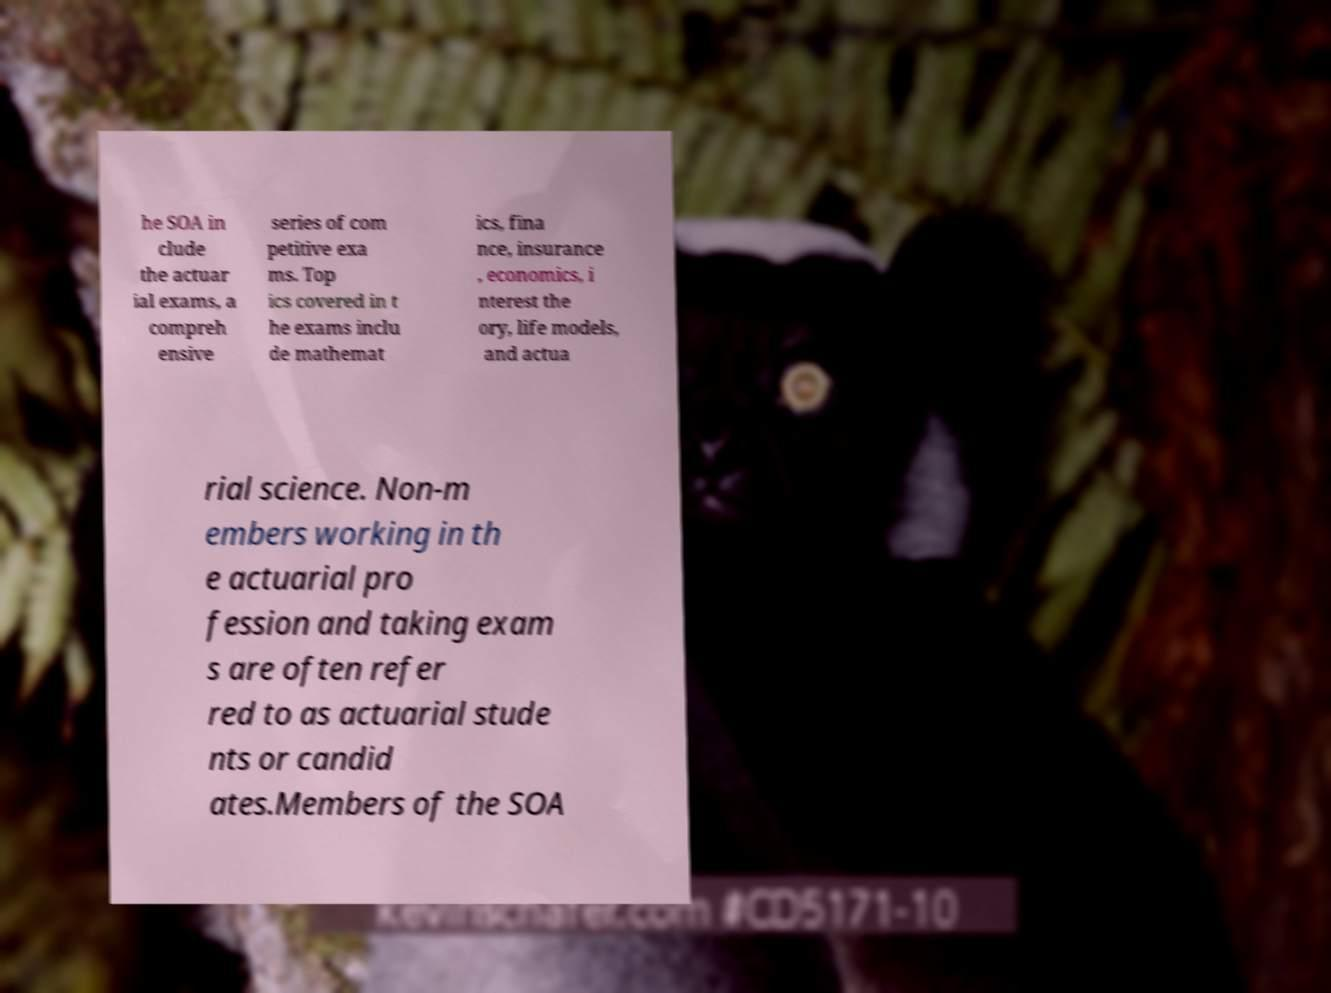I need the written content from this picture converted into text. Can you do that? he SOA in clude the actuar ial exams, a compreh ensive series of com petitive exa ms. Top ics covered in t he exams inclu de mathemat ics, fina nce, insurance , economics, i nterest the ory, life models, and actua rial science. Non-m embers working in th e actuarial pro fession and taking exam s are often refer red to as actuarial stude nts or candid ates.Members of the SOA 